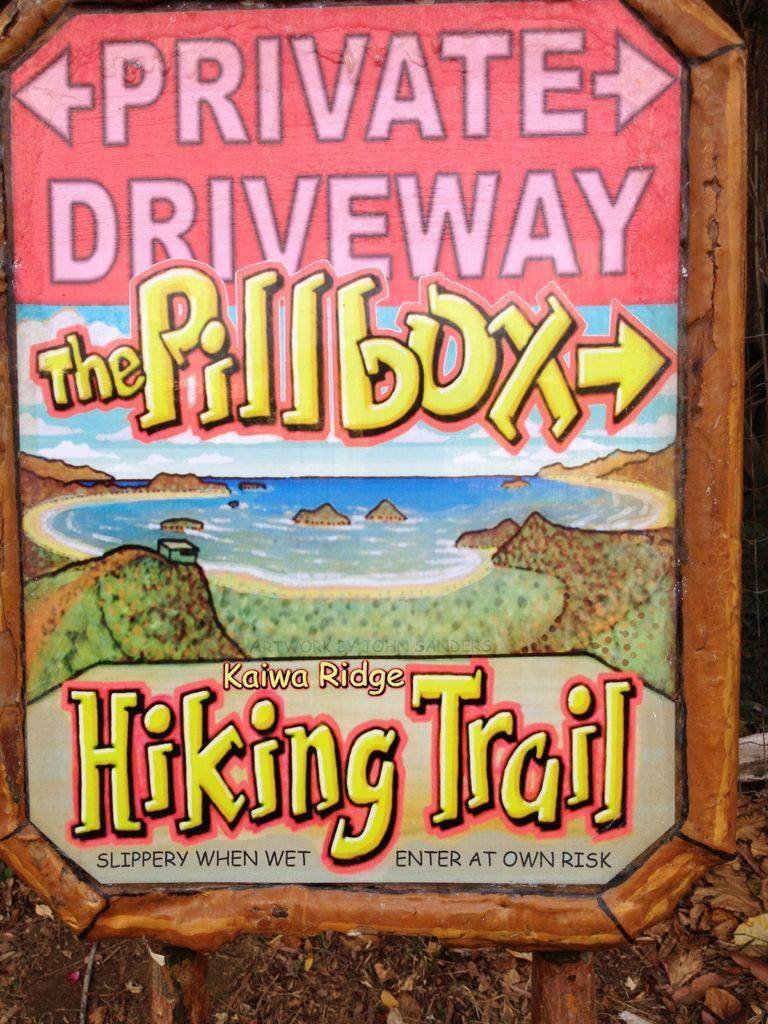<image>
Render a clear and concise summary of the photo. The hiking trail sign tells you to head to the right to go to the Pillbox. 